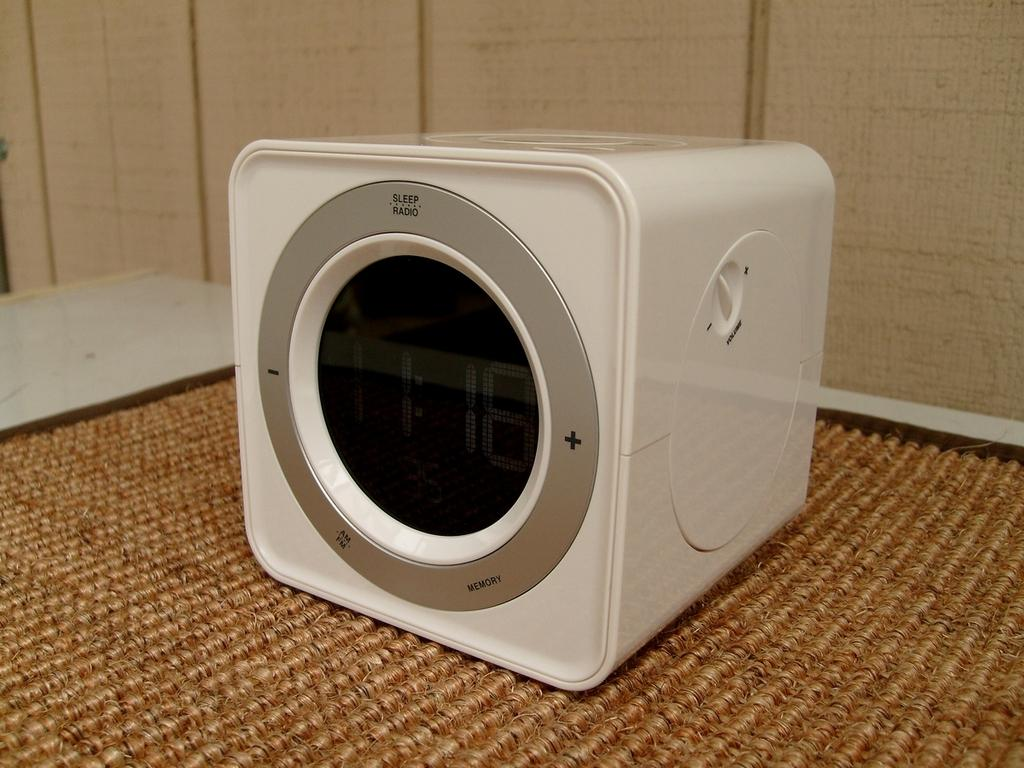What is on the floor in the image? There is a mat in the image. What is placed on the mat? There is a digital clock on the mat. What can be seen in the background of the image? There is a wall in the background of the image. Can you tell me how many horses are depicted on the mat? There are no horses depicted on the mat; it features a digital clock. What shape is the observation window in the image? There is no observation window present in the image. 